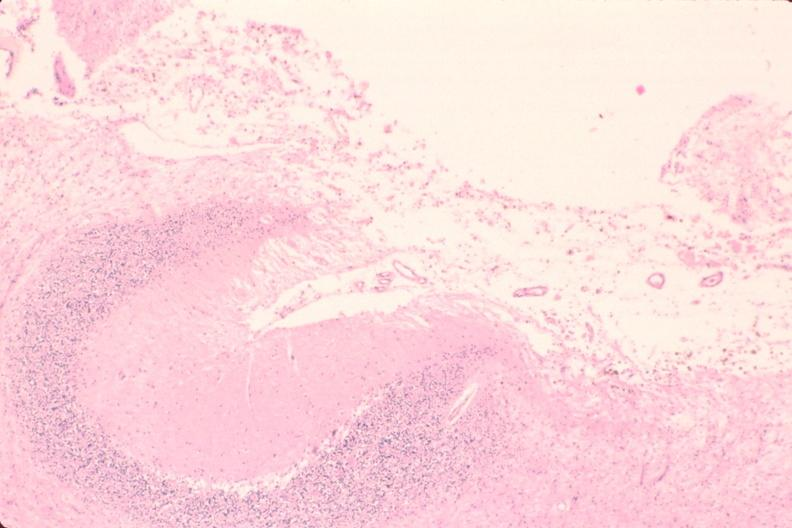what is present?
Answer the question using a single word or phrase. Nervous 